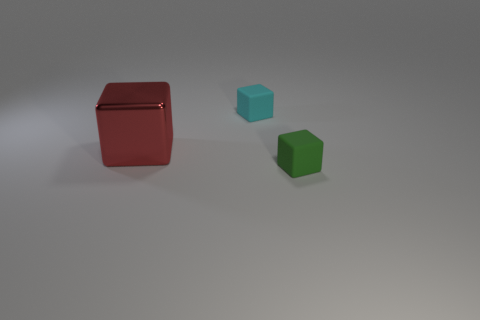Are the cyan object and the large red thing made of the same material?
Provide a short and direct response. No. What number of matte cubes are left of the small object that is behind the small matte cube that is to the right of the cyan thing?
Keep it short and to the point. 0. The tiny object that is right of the tiny cyan block has what shape?
Ensure brevity in your answer.  Cube. What number of other objects are there of the same material as the green thing?
Your response must be concise. 1. Are there fewer blocks to the right of the big red shiny object than small rubber things left of the green rubber cube?
Give a very brief answer. No. There is another small matte object that is the same shape as the cyan rubber thing; what color is it?
Keep it short and to the point. Green. There is a rubber cube behind the shiny thing; is it the same size as the tiny green rubber block?
Ensure brevity in your answer.  Yes. Are there fewer red things behind the cyan rubber thing than red things?
Provide a short and direct response. Yes. Is there any other thing that has the same size as the cyan matte cube?
Provide a short and direct response. Yes. What size is the rubber object to the left of the matte cube in front of the large red metal object?
Offer a very short reply. Small. 